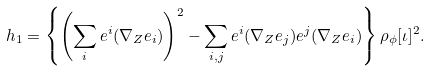<formula> <loc_0><loc_0><loc_500><loc_500>h _ { 1 } = \left \{ \left ( \sum _ { i } e ^ { i } ( \nabla _ { Z } e _ { i } ) \right ) ^ { 2 } - \sum _ { i , j } e ^ { i } ( \nabla _ { Z } e _ { j } ) e ^ { j } ( \nabla _ { Z } e _ { i } ) \right \} \rho _ { \phi } [ \iota ] ^ { 2 } .</formula> 